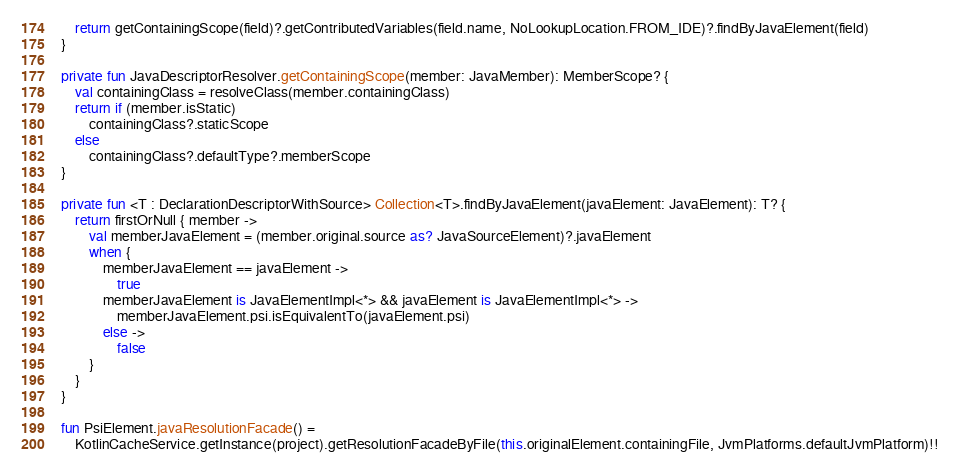<code> <loc_0><loc_0><loc_500><loc_500><_Kotlin_>    return getContainingScope(field)?.getContributedVariables(field.name, NoLookupLocation.FROM_IDE)?.findByJavaElement(field)
}

private fun JavaDescriptorResolver.getContainingScope(member: JavaMember): MemberScope? {
    val containingClass = resolveClass(member.containingClass)
    return if (member.isStatic)
        containingClass?.staticScope
    else
        containingClass?.defaultType?.memberScope
}

private fun <T : DeclarationDescriptorWithSource> Collection<T>.findByJavaElement(javaElement: JavaElement): T? {
    return firstOrNull { member ->
        val memberJavaElement = (member.original.source as? JavaSourceElement)?.javaElement
        when {
            memberJavaElement == javaElement ->
                true
            memberJavaElement is JavaElementImpl<*> && javaElement is JavaElementImpl<*> ->
                memberJavaElement.psi.isEquivalentTo(javaElement.psi)
            else ->
                false
        }
    }
}

fun PsiElement.javaResolutionFacade() =
    KotlinCacheService.getInstance(project).getResolutionFacadeByFile(this.originalElement.containingFile, JvmPlatforms.defaultJvmPlatform)!!
</code> 